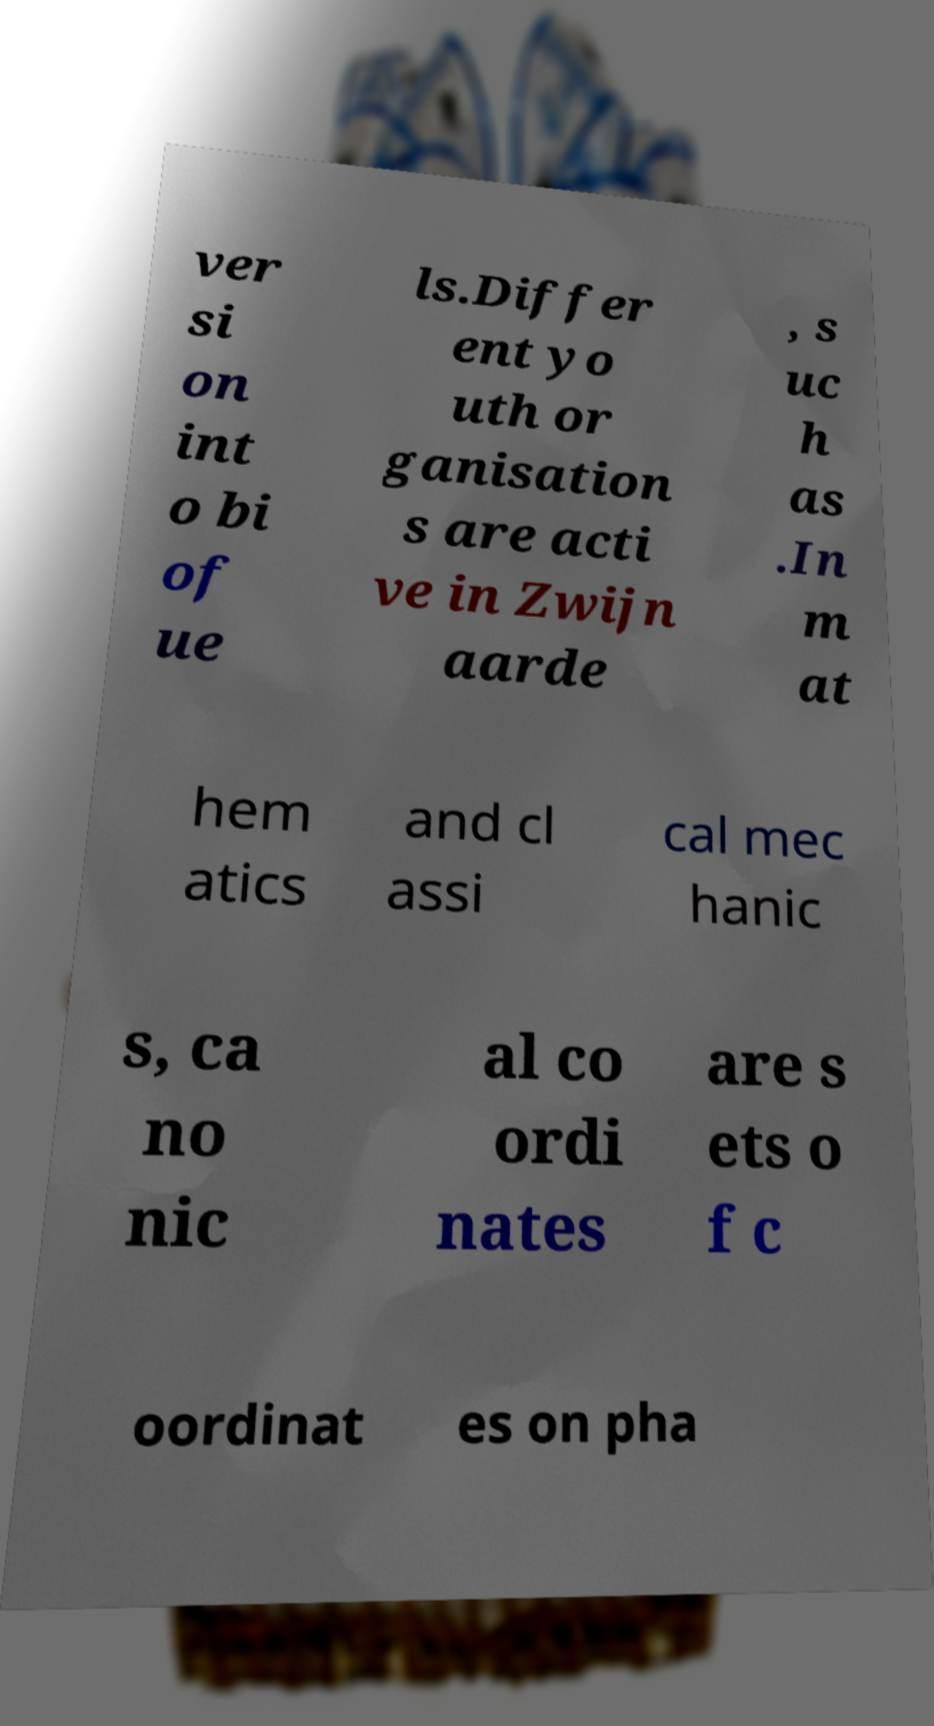What messages or text are displayed in this image? I need them in a readable, typed format. ver si on int o bi of ue ls.Differ ent yo uth or ganisation s are acti ve in Zwijn aarde , s uc h as .In m at hem atics and cl assi cal mec hanic s, ca no nic al co ordi nates are s ets o f c oordinat es on pha 